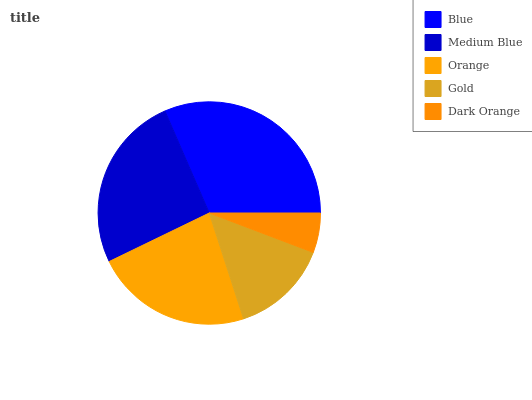Is Dark Orange the minimum?
Answer yes or no. Yes. Is Blue the maximum?
Answer yes or no. Yes. Is Medium Blue the minimum?
Answer yes or no. No. Is Medium Blue the maximum?
Answer yes or no. No. Is Blue greater than Medium Blue?
Answer yes or no. Yes. Is Medium Blue less than Blue?
Answer yes or no. Yes. Is Medium Blue greater than Blue?
Answer yes or no. No. Is Blue less than Medium Blue?
Answer yes or no. No. Is Orange the high median?
Answer yes or no. Yes. Is Orange the low median?
Answer yes or no. Yes. Is Blue the high median?
Answer yes or no. No. Is Dark Orange the low median?
Answer yes or no. No. 